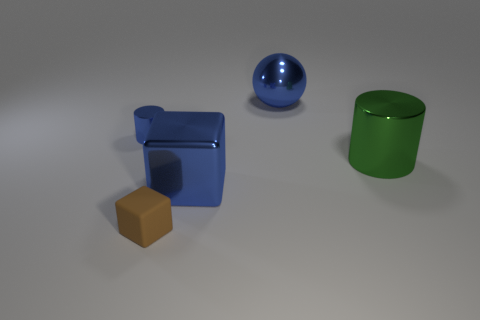The shiny thing that is the same shape as the brown rubber thing is what size?
Your answer should be very brief. Large. What color is the other metal object that is the same shape as the small blue metallic thing?
Make the answer very short. Green. There is a cube right of the tiny brown cube; how many large objects are right of it?
Provide a short and direct response. 2. There is a small thing that is in front of the blue cylinder; does it have the same color as the tiny shiny thing to the left of the tiny matte thing?
Your answer should be compact. No. There is a large object that is both on the left side of the big green cylinder and behind the large cube; what is its shape?
Give a very brief answer. Sphere. Are there any yellow metallic things of the same shape as the tiny matte object?
Provide a short and direct response. No. The green object that is the same size as the metallic sphere is what shape?
Ensure brevity in your answer.  Cylinder. What material is the large green thing?
Your answer should be compact. Metal. What size is the metallic cylinder left of the blue shiny sphere behind the cylinder behind the large green cylinder?
Keep it short and to the point. Small. There is a cube that is the same color as the tiny cylinder; what material is it?
Provide a succinct answer. Metal. 